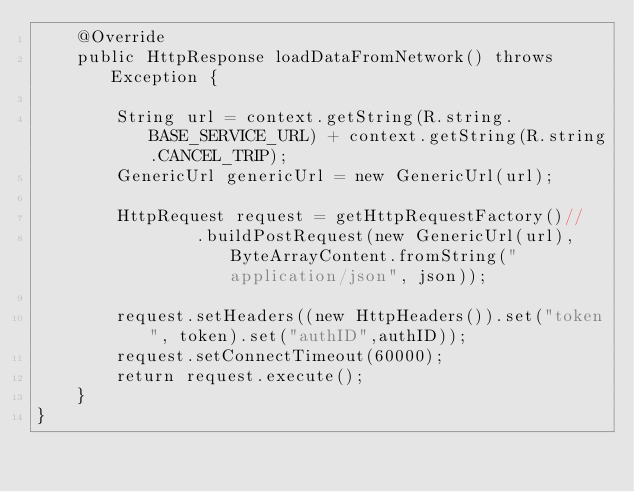<code> <loc_0><loc_0><loc_500><loc_500><_Java_>    @Override
    public HttpResponse loadDataFromNetwork() throws Exception {

        String url = context.getString(R.string.BASE_SERVICE_URL) + context.getString(R.string.CANCEL_TRIP);
        GenericUrl genericUrl = new GenericUrl(url);

        HttpRequest request = getHttpRequestFactory()//
                .buildPostRequest(new GenericUrl(url), ByteArrayContent.fromString("application/json", json));

        request.setHeaders((new HttpHeaders()).set("token", token).set("authID",authID));
        request.setConnectTimeout(60000);
        return request.execute();
    }
}
</code> 